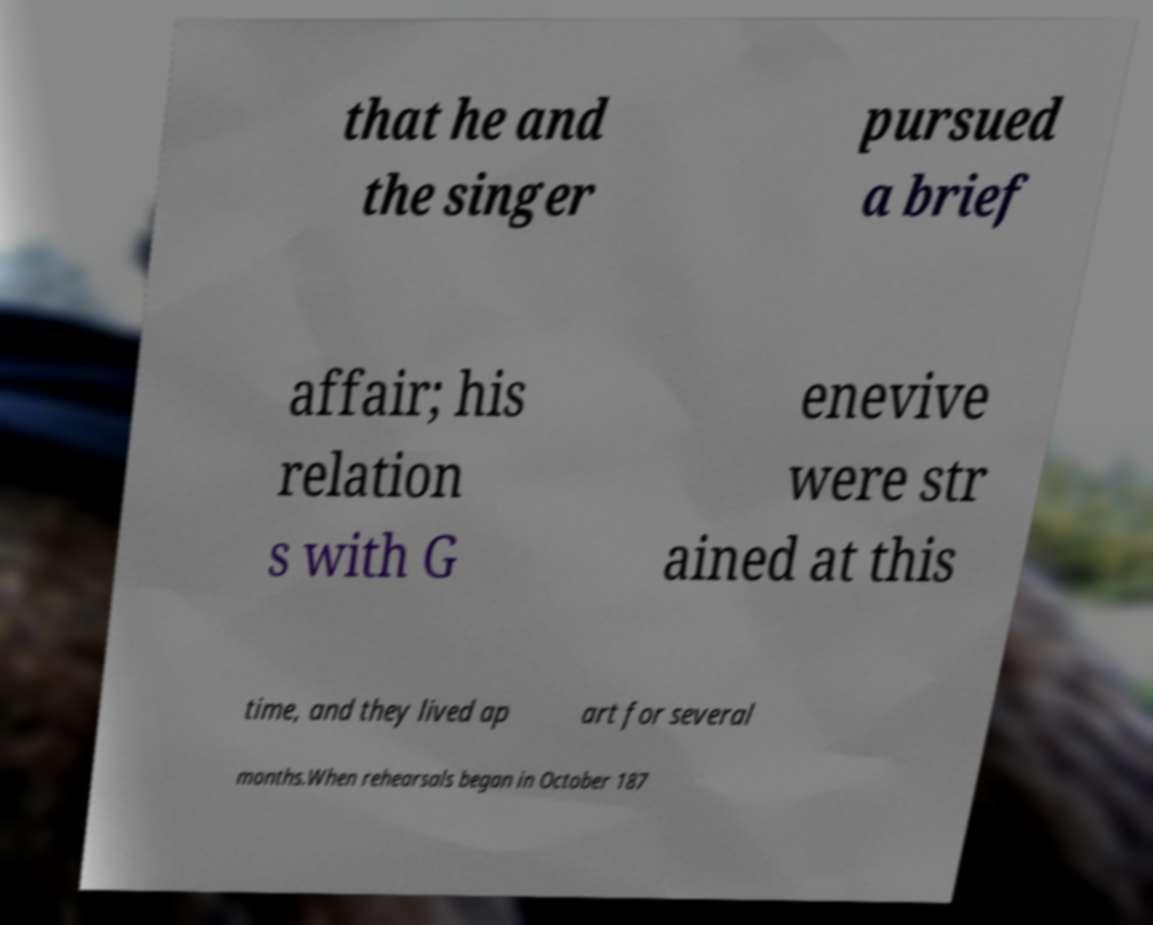I need the written content from this picture converted into text. Can you do that? that he and the singer pursued a brief affair; his relation s with G enevive were str ained at this time, and they lived ap art for several months.When rehearsals began in October 187 